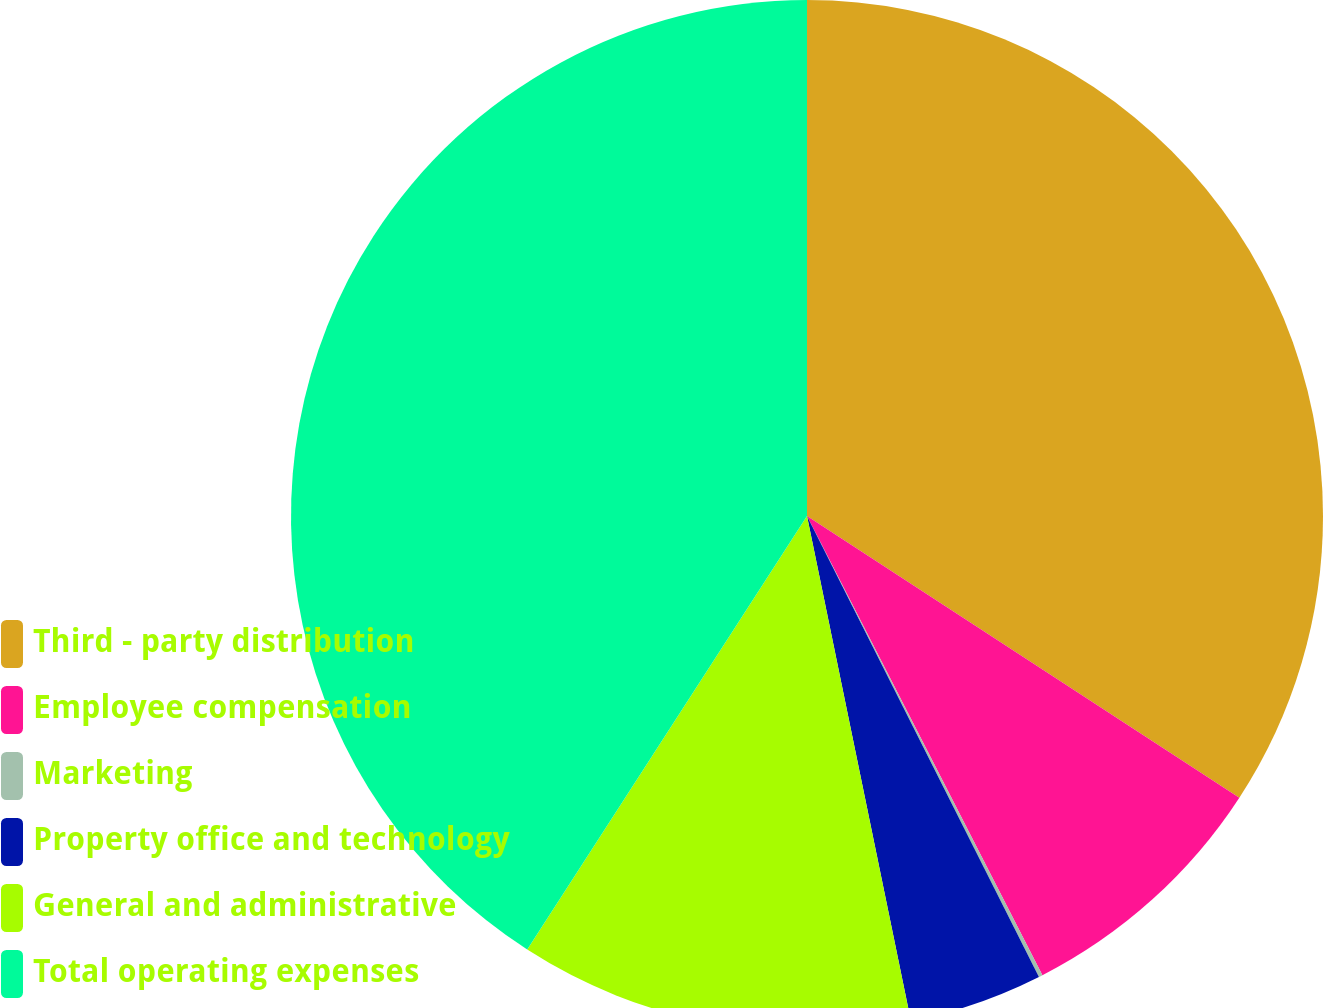Convert chart. <chart><loc_0><loc_0><loc_500><loc_500><pie_chart><fcel>Third - party distribution<fcel>Employee compensation<fcel>Marketing<fcel>Property office and technology<fcel>General and administrative<fcel>Total operating expenses<nl><fcel>34.19%<fcel>8.27%<fcel>0.12%<fcel>4.19%<fcel>12.35%<fcel>40.88%<nl></chart> 